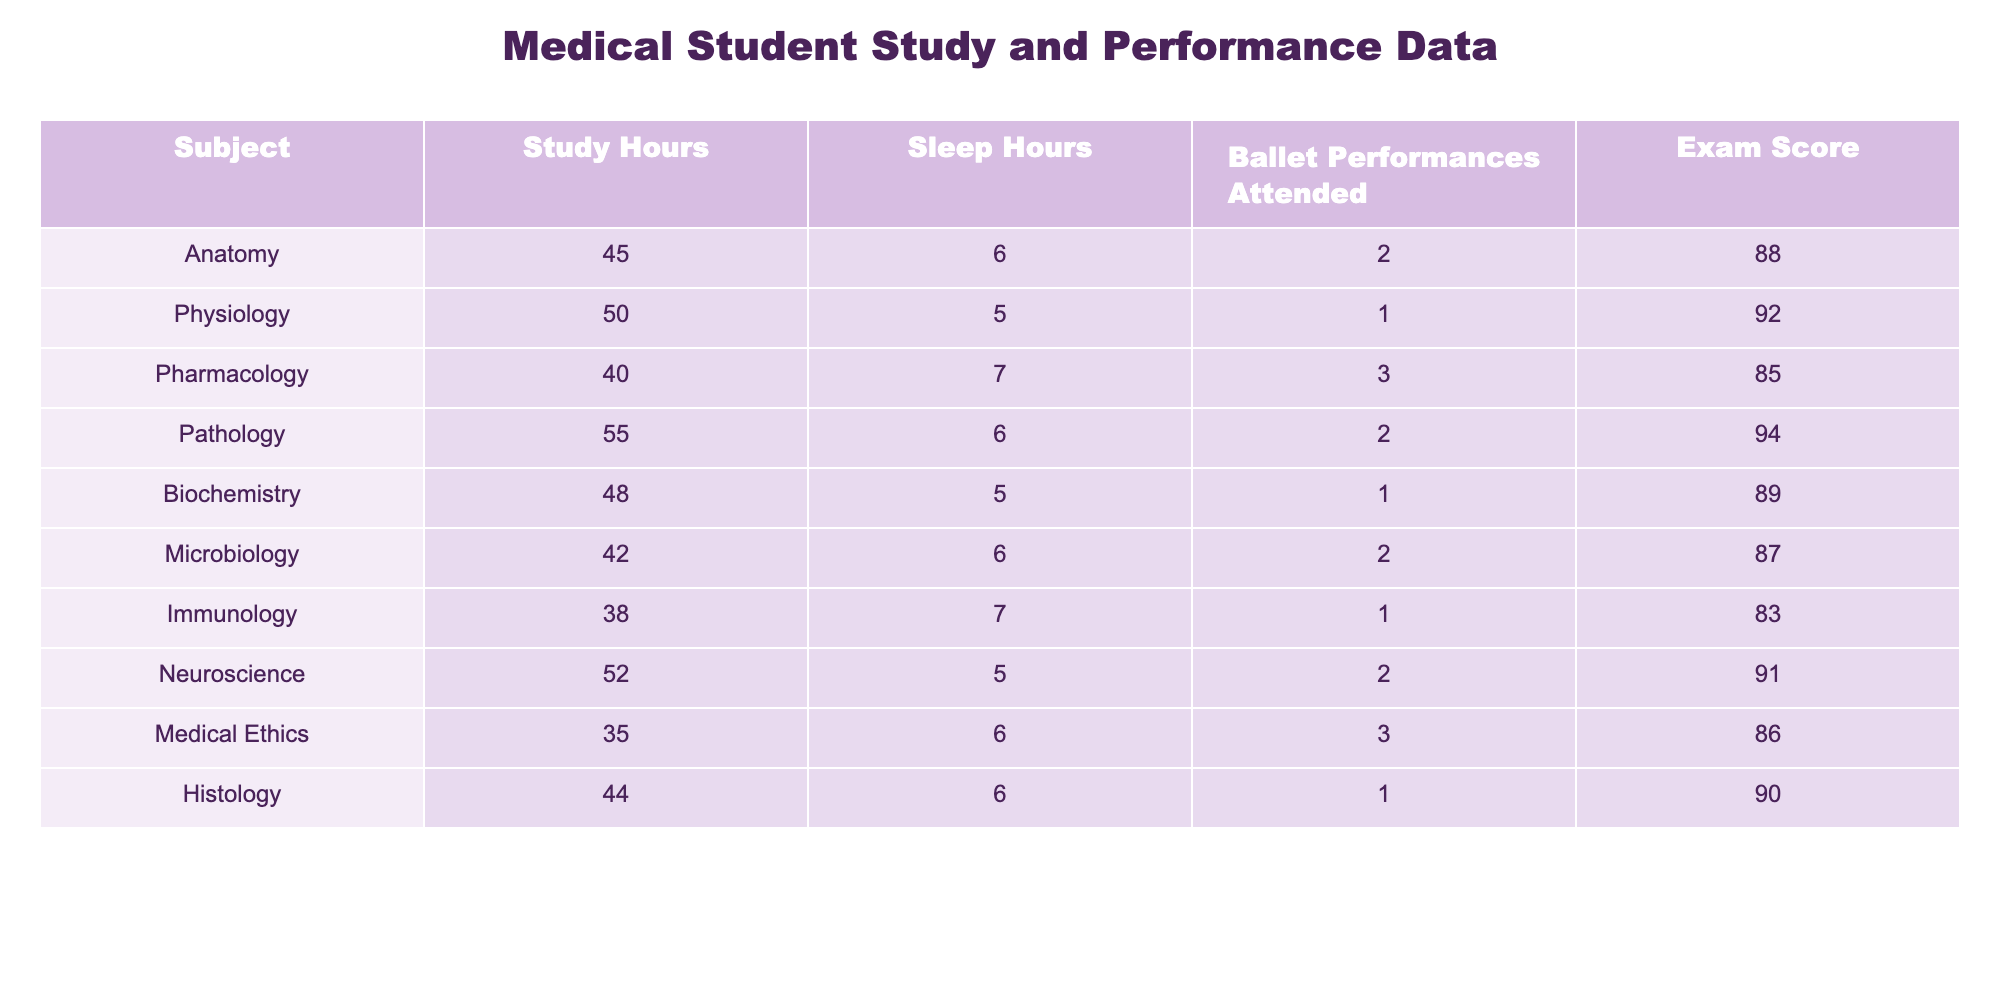What is the exam score for Pharmacology? The exam score for Pharmacology is listed directly in the table under the 'Exam Score' column for that subject.
Answer: 85 How many study hours were allocated for Pathology? The number of study hours for Pathology is provided in the 'Study Hours' column next to the subject name.
Answer: 55 What is the average exam score across all subjects? To calculate the average, sum the exam scores (88 + 92 + 85 + 94 + 89 + 87 + 83 + 91 + 86 + 90 = 905) and divide by the number of subjects (10), resulting in an average score of 905 / 10 = 90.5.
Answer: 90.5 Is the statement "Immunology had less study hours than Biochemistry" true? By comparing the 'Study Hours' for Immunology (38) and Biochemistry (48), we see that Immunology had less study hours, confirming the statement to be true.
Answer: Yes What is the total number of ballet performances attended across all subjects? To find the total, sum the 'Ballet Performances Attended' values (2 + 1 + 3 + 2 + 1 + 2 + 1 + 2 + 3 + 1 = 18).
Answer: 18 Which subject has the highest sleep hours and what is the score for that subject? The subject with the highest sleep hours is Pharmacology (7 sleep hours), and its exam score is 85, as noted in the table.
Answer: Pharmacology, 85 If a medical student studied 50 hours, what is the expected exam score based on the provided data? The exam scores for subjects with study hours close to 50 are Physiology (92), Pathology (94), and Neuroscience (91). A rough estimate around this study hour would suggest a score in that range, typically around 91.
Answer: Approximately 91 Which subject scored below the average exam score, and what is that score? The average score is 90.5. The subjects that scored below it are Pharmacology (85) and Immunology (83).
Answer: Pharmacology (85) and Immunology (83) How does the exam score for Microbiology compare to the exam score for Anatomy? The score for Microbiology is 87, while the score for Anatomy is 88. Microbiology has a lower score than Anatomy by 1 point.
Answer: Microbiology is 1 point lower than Anatomy Are there any subjects with 6 sleep hours that scored above 90? The subjects with 6 sleep hours are Anatomy, Pathology, Microbiology, and Histology. Among these, only Pathology (94) scored above 90.
Answer: Yes, Pathology scored above 90 